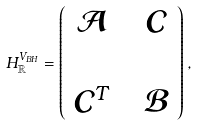Convert formula to latex. <formula><loc_0><loc_0><loc_500><loc_500>H _ { \mathbb { R } } ^ { V _ { B H } } = \left ( \begin{array} { c c c } \mathcal { A } & & \mathcal { C } \\ & & \\ \mathcal { C } ^ { T } & & \mathcal { B } \end{array} \right ) ,</formula> 